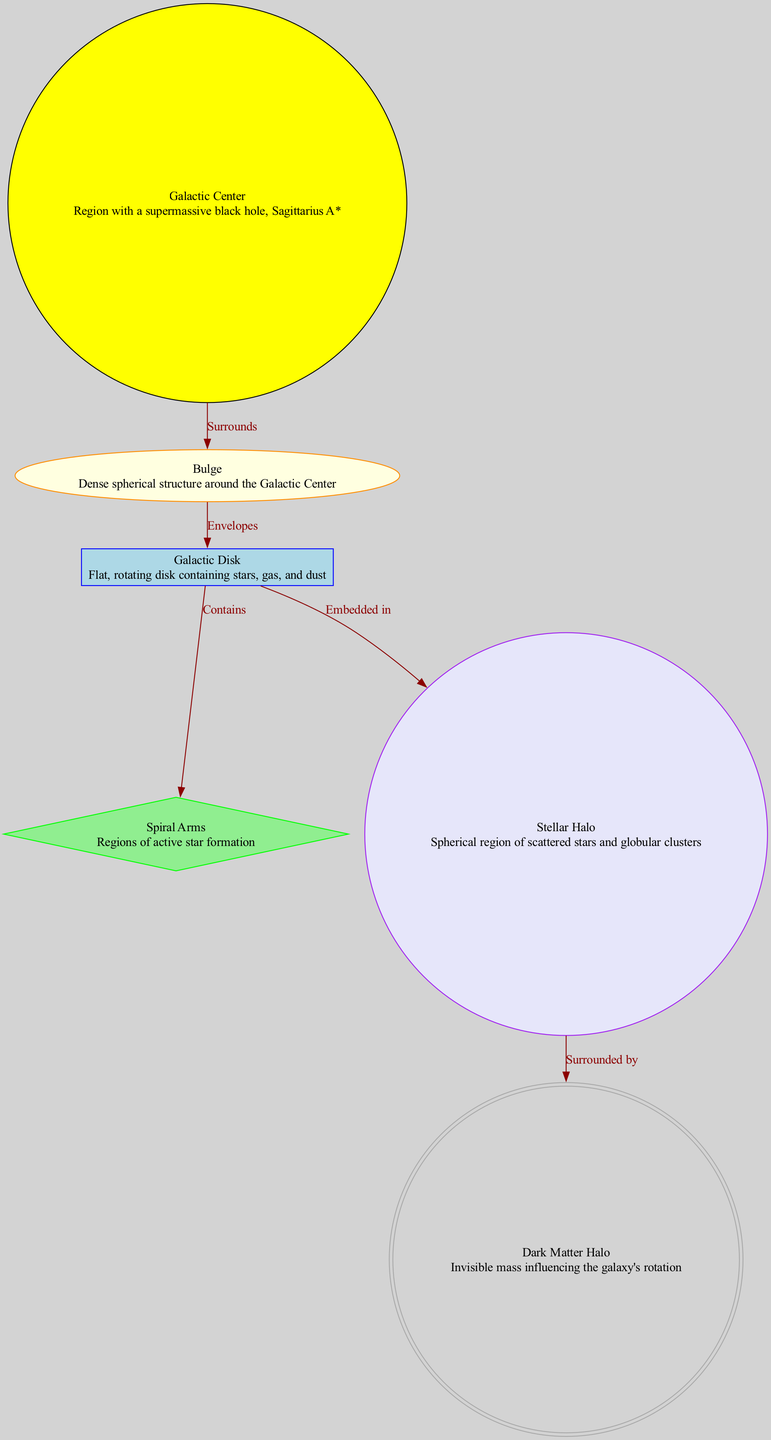What is at the center of the Milky Way Galaxy? The diagram identifies the "Galactic Center" as the center of the Milky Way Galaxy, which contains the supermassive black hole Sagittarius A*.
Answer: Galactic Center How many main structural components are represented in the diagram? The diagram presents six main components: Galactic Center, Bulge, Galactic Disk, Spiral Arms, Stellar Halo, and Dark Matter Halo. Counting these nodes confirms there are six components.
Answer: 6 What surrounds the Stellar Halo? According to the diagram, the "Dark Matter Halo" surrounds the Stellar Halo. The edge labeled "Surrounded by" explicitly indicates this relationship.
Answer: Dark Matter Halo What does the Galactic Disk contain? The diagram specifies that the Galactic Disk "Contains" the Spiral Arms. Thus, the answer to what the disk contains is the Spiral Arms.
Answer: Spiral Arms What is the relationship between the Bulge and the Disk? The connection indicated in the diagram shows that the Bulge "Envelopes" the Disk. This is a direct relationship captured by the edge labeled "Envelopes."
Answer: Envelopes What is primarily located in the Spiral Arms? The diagram describes the Spiral Arms as regions of active star formation, indicating that this is their primary function.
Answer: Regions of active star formation How are the Bulge and the Galactic Center related? The diagram shows that the Bulge "Surrounds" the Galactic Center, demonstrating that the Bulge is an outer structure enclosing the Galactic Center.
Answer: Surrounds What type of structure is the Galactic Disk? The diagram describes the Galactic Disk as a "Flat, rotating disk." This provides a clear characterization of its geometry and dynamics.
Answer: Flat, rotating disk Which component is described as having a supermassive black hole? The diagram clearly labels the Galactic Center as the region that contains a supermassive black hole named Sagittarius A*, making it the component of interest.
Answer: Galactic Center 